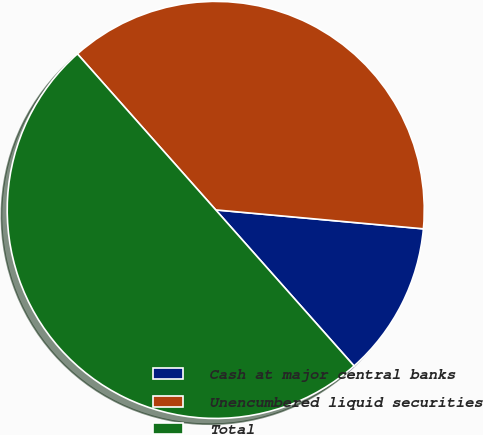<chart> <loc_0><loc_0><loc_500><loc_500><pie_chart><fcel>Cash at major central banks<fcel>Unencumbered liquid securities<fcel>Total<nl><fcel>12.01%<fcel>37.99%<fcel>50.0%<nl></chart> 